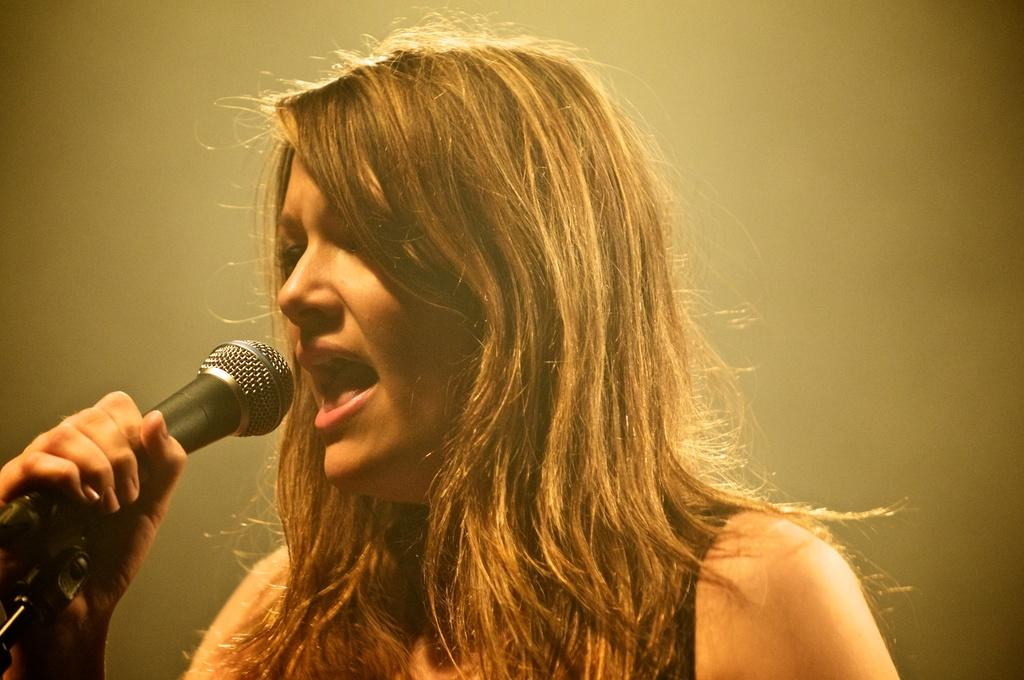Who is the main subject in the image? There is a woman in the image. What is the woman doing in the image? The woman is singing. What object is the woman holding while singing? The woman is holding a microphone (mike) in the image. What type of corn can be seen growing in the background of the image? There is no corn visible in the image; it features a woman singing while holding a microphone. 